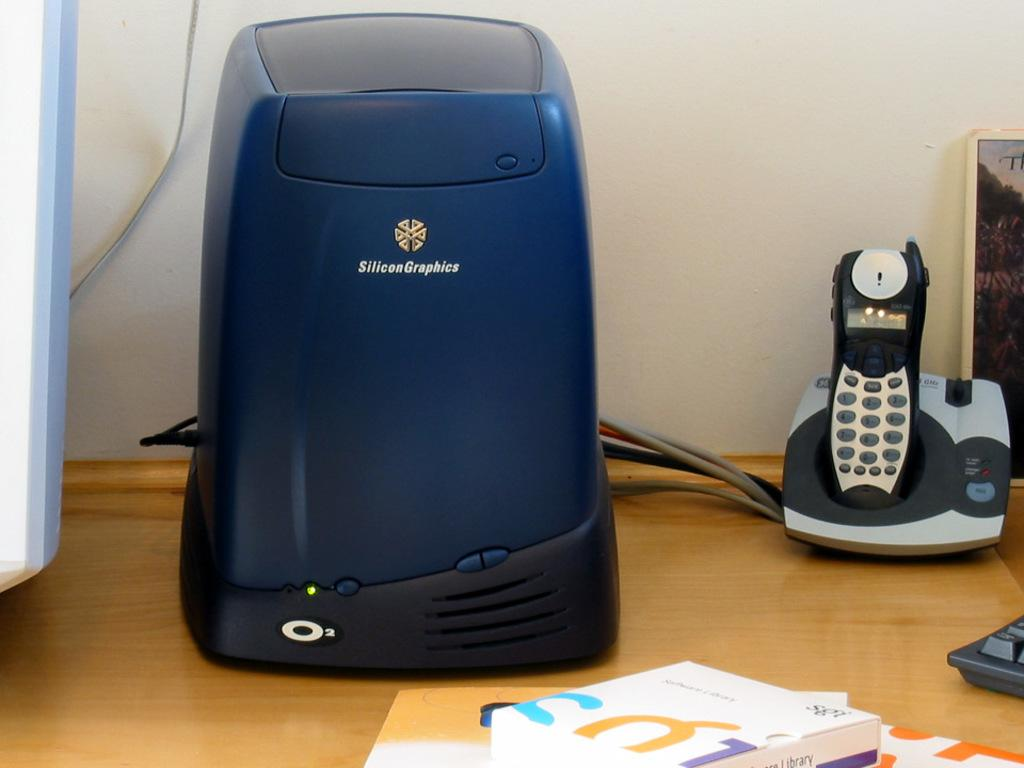Provide a one-sentence caption for the provided image. an electronics item with Silicon Graphics on it. 